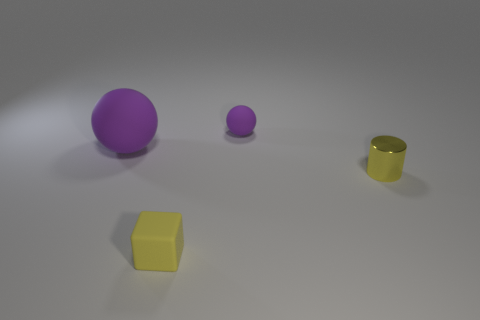How would you describe the overall atmosphere or mood of this scene? The scene has a minimalist, tranquil vibe, with a neutral background and soft lighting. The sparse arrangement of objects and the soft shadows they cast contribute to a calm and contemplative mood. 